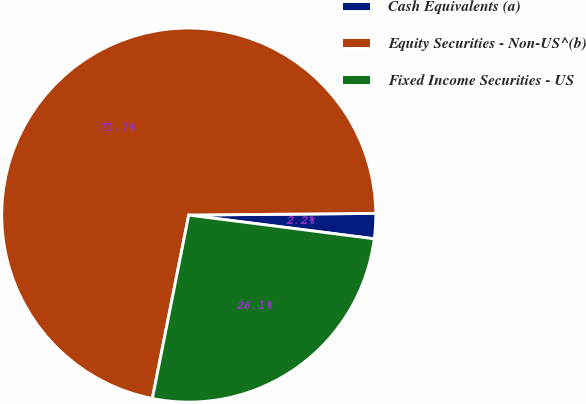Convert chart. <chart><loc_0><loc_0><loc_500><loc_500><pie_chart><fcel>Cash Equivalents (a)<fcel>Equity Securities - Non-US^(b)<fcel>Fixed Income Securities - US<nl><fcel>2.17%<fcel>71.74%<fcel>26.09%<nl></chart> 